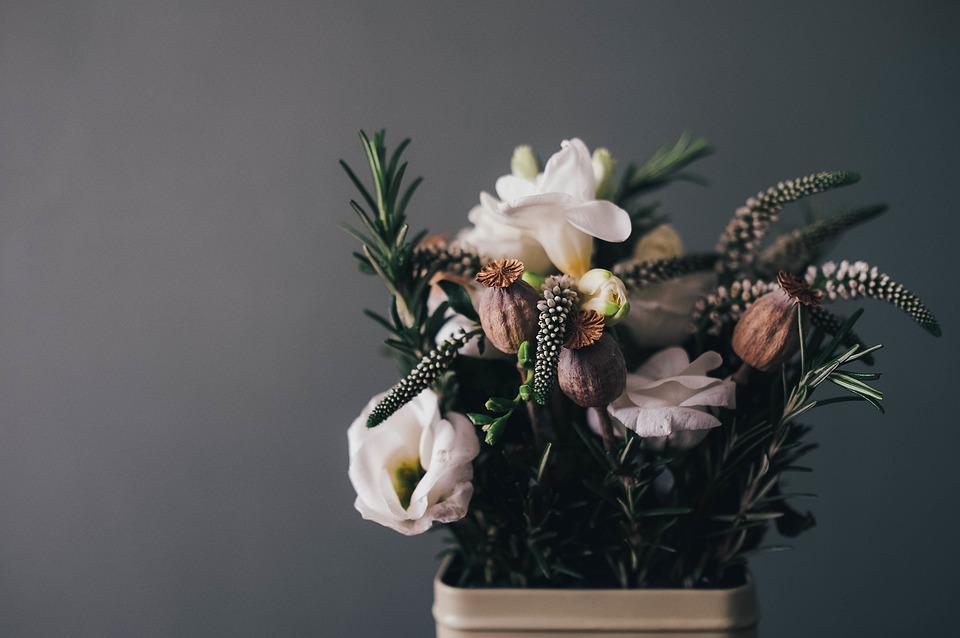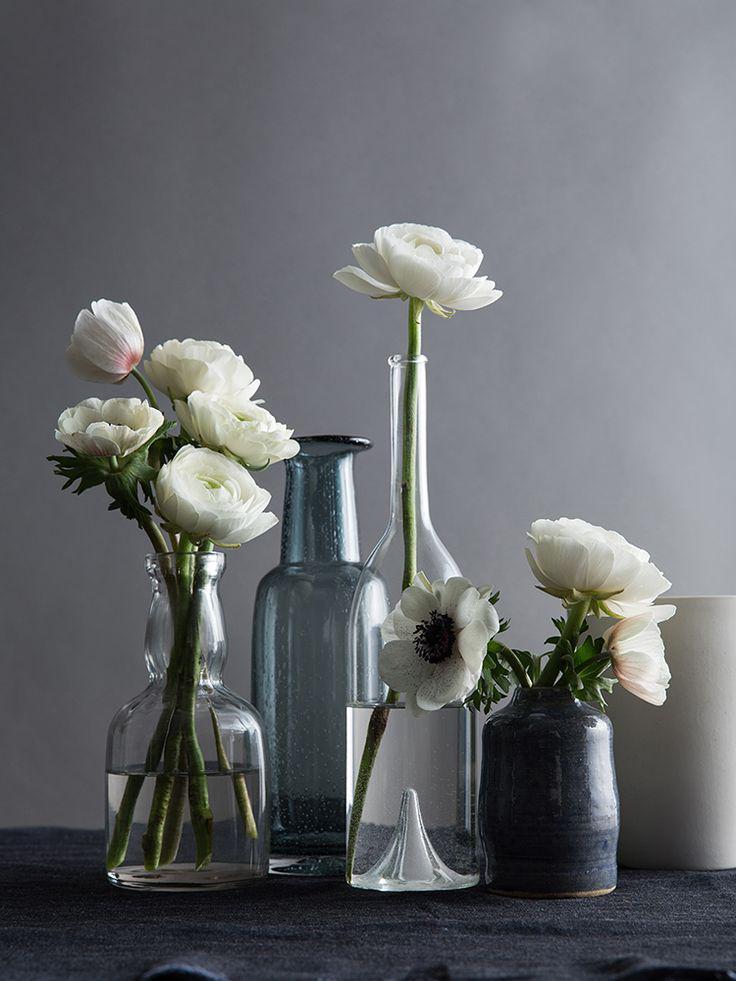The first image is the image on the left, the second image is the image on the right. Analyze the images presented: Is the assertion "There are multiple vases in the right image with the centre one the highest." valid? Answer yes or no. Yes. 